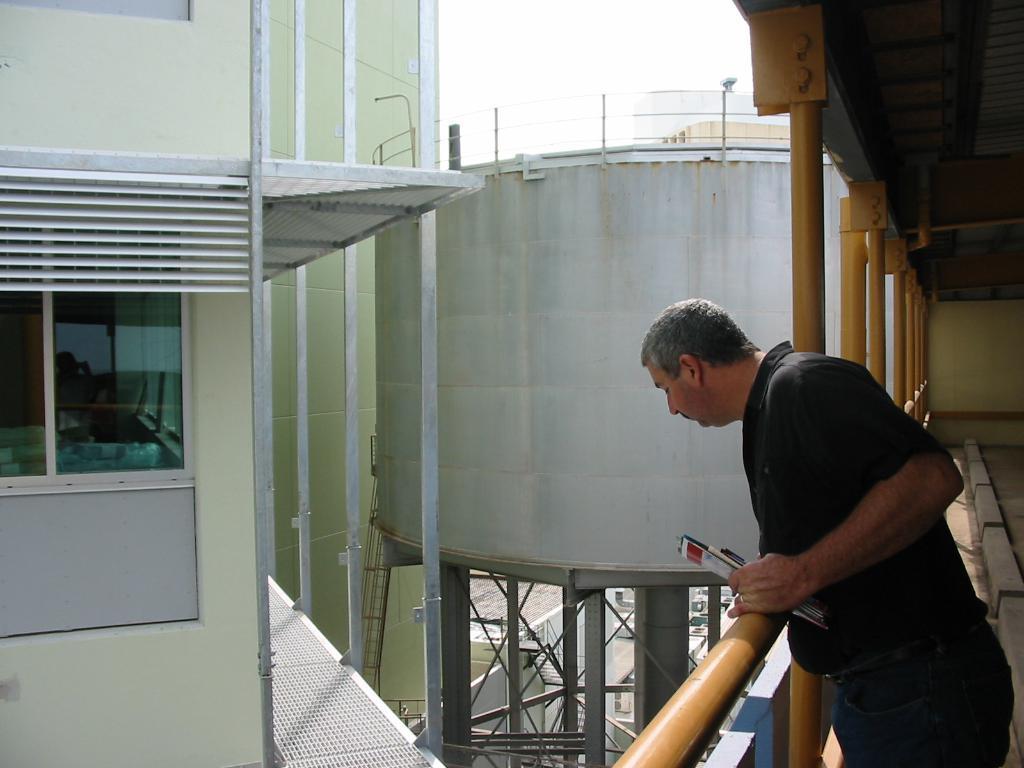Can you describe this image briefly? Here we can see a man looking downwards and he is holding papers with his hands. Here we can see a building, glass window, poles, and a tanker. In the background there is sky. 